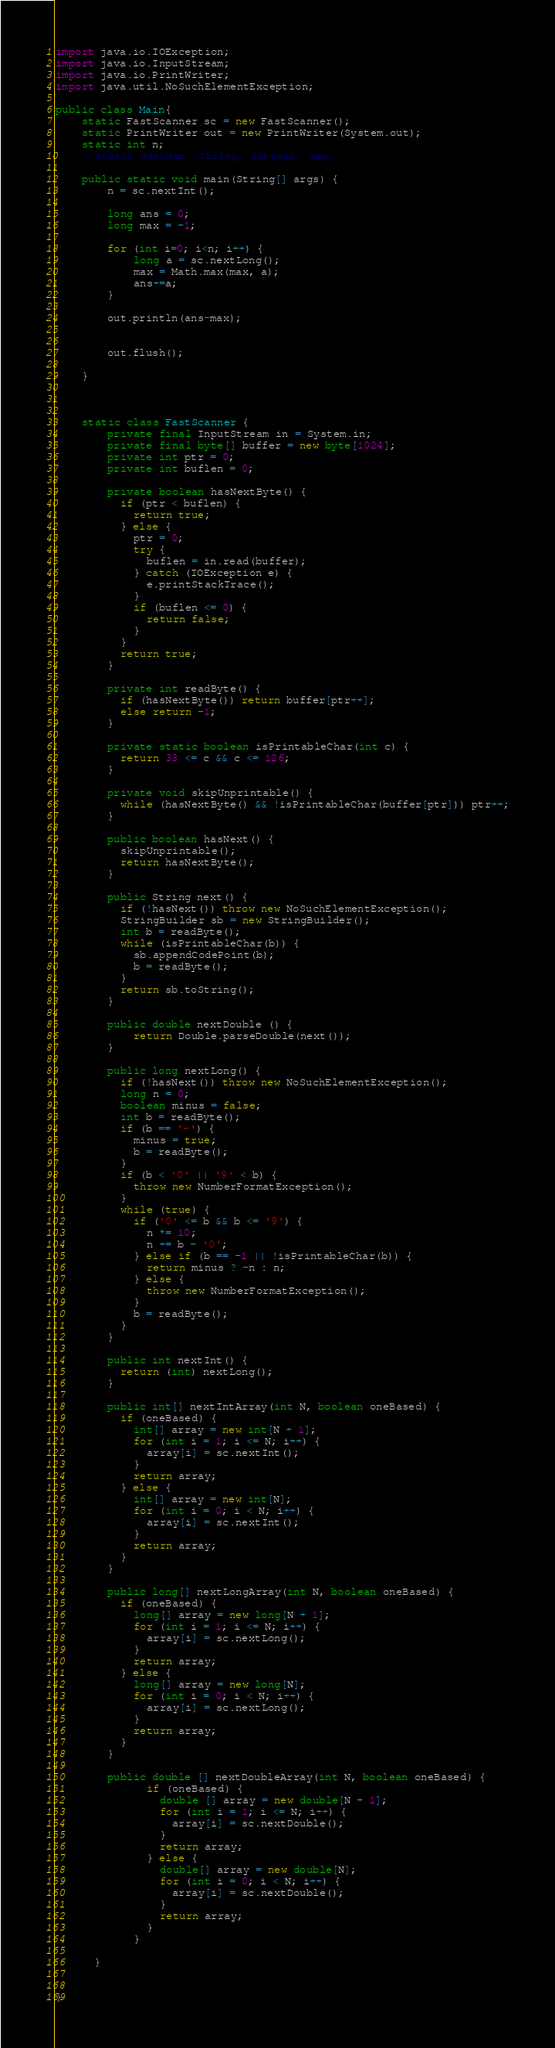<code> <loc_0><loc_0><loc_500><loc_500><_Java_>import java.io.IOException;
import java.io.InputStream;
import java.io.PrintWriter;
import java.util.NoSuchElementException;

public class Main{
	static FastScanner sc = new FastScanner();
	static PrintWriter out = new PrintWriter(System.out);
	static int n;
	//static HashMap <String, Integer> map;
	
	public static void main(String[] args) {
		n = sc.nextInt();
		
		long ans = 0;
		long max = -1;
		
		for (int i=0; i<n; i++) {
			long a = sc.nextLong();
			max = Math.max(max, a);
			ans+=a;
		}
		
		out.println(ans-max);
		
		
		out.flush();
		
	}
	
	
	
	static class FastScanner {
	    private final InputStream in = System.in;
	    private final byte[] buffer = new byte[1024];
	    private int ptr = 0;
	    private int buflen = 0;

	    private boolean hasNextByte() {
	      if (ptr < buflen) {
	        return true;
	      } else {
	        ptr = 0;
	        try {
	          buflen = in.read(buffer);
	        } catch (IOException e) {
	          e.printStackTrace();
	        }
	        if (buflen <= 0) {
	          return false;
	        }
	      }
	      return true;
	    }

	    private int readByte() {
	      if (hasNextByte()) return buffer[ptr++];
	      else return -1;
	    }

	    private static boolean isPrintableChar(int c) {
	      return 33 <= c && c <= 126;
	    }

	    private void skipUnprintable() {
	      while (hasNextByte() && !isPrintableChar(buffer[ptr])) ptr++;
	    }

	    public boolean hasNext() {
	      skipUnprintable();
	      return hasNextByte();
	    }

	    public String next() {
	      if (!hasNext()) throw new NoSuchElementException();
	      StringBuilder sb = new StringBuilder();
	      int b = readByte();
	      while (isPrintableChar(b)) {
	        sb.appendCodePoint(b);
	        b = readByte();
	      }
	      return sb.toString();
	    }
	    
	    public double nextDouble () {
	    	return Double.parseDouble(next());
	    }

	    public long nextLong() {
	      if (!hasNext()) throw new NoSuchElementException();
	      long n = 0;
	      boolean minus = false;
	      int b = readByte();
	      if (b == '-') {
	        minus = true;
	        b = readByte();
	      }
	      if (b < '0' || '9' < b) {
	        throw new NumberFormatException();
	      }
	      while (true) {
	        if ('0' <= b && b <= '9') {
	          n *= 10;
	          n += b - '0';
	        } else if (b == -1 || !isPrintableChar(b)) {
	          return minus ? -n : n;
	        } else {
	          throw new NumberFormatException();
	        }
	        b = readByte();
	      }
	    }

	    public int nextInt() {
	      return (int) nextLong();
	    }

	    public int[] nextIntArray(int N, boolean oneBased) {
	      if (oneBased) {
	        int[] array = new int[N + 1];
	        for (int i = 1; i <= N; i++) {
	          array[i] = sc.nextInt();
	        }
	        return array;
	      } else {
	        int[] array = new int[N];
	        for (int i = 0; i < N; i++) {
	          array[i] = sc.nextInt();
	        }
	        return array;
	      }
	    }

	    public long[] nextLongArray(int N, boolean oneBased) {
	      if (oneBased) {
	        long[] array = new long[N + 1];
	        for (int i = 1; i <= N; i++) {
	          array[i] = sc.nextLong();
	        }
	        return array;
	      } else {
	        long[] array = new long[N];
	        for (int i = 0; i < N; i++) {
	          array[i] = sc.nextLong();
	        }
	        return array;
	      }
	    }
	    
	    public double [] nextDoubleArray(int N, boolean oneBased) {
		      if (oneBased) {
		        double [] array = new double[N + 1];
		        for (int i = 1; i <= N; i++) {
		          array[i] = sc.nextDouble();
		        }
		        return array;
		      } else {
		        double[] array = new double[N];
		        for (int i = 0; i < N; i++) {
		          array[i] = sc.nextDouble();
		        }
		        return array;
		      }
		    }
		  
	  }
	
	
}
</code> 